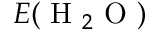<formula> <loc_0><loc_0><loc_500><loc_500>E ( H _ { 2 } O )</formula> 